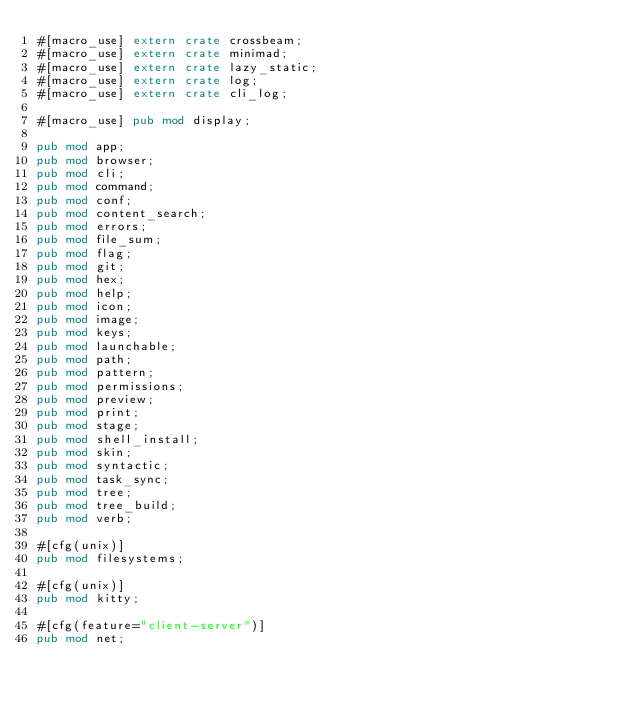Convert code to text. <code><loc_0><loc_0><loc_500><loc_500><_Rust_>#[macro_use] extern crate crossbeam;
#[macro_use] extern crate minimad;
#[macro_use] extern crate lazy_static;
#[macro_use] extern crate log;
#[macro_use] extern crate cli_log;

#[macro_use] pub mod display;

pub mod app;
pub mod browser;
pub mod cli;
pub mod command;
pub mod conf;
pub mod content_search;
pub mod errors;
pub mod file_sum;
pub mod flag;
pub mod git;
pub mod hex;
pub mod help;
pub mod icon;
pub mod image;
pub mod keys;
pub mod launchable;
pub mod path;
pub mod pattern;
pub mod permissions;
pub mod preview;
pub mod print;
pub mod stage;
pub mod shell_install;
pub mod skin;
pub mod syntactic;
pub mod task_sync;
pub mod tree;
pub mod tree_build;
pub mod verb;

#[cfg(unix)]
pub mod filesystems;

#[cfg(unix)]
pub mod kitty;

#[cfg(feature="client-server")]
pub mod net;
</code> 